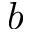Convert formula to latex. <formula><loc_0><loc_0><loc_500><loc_500>b</formula> 